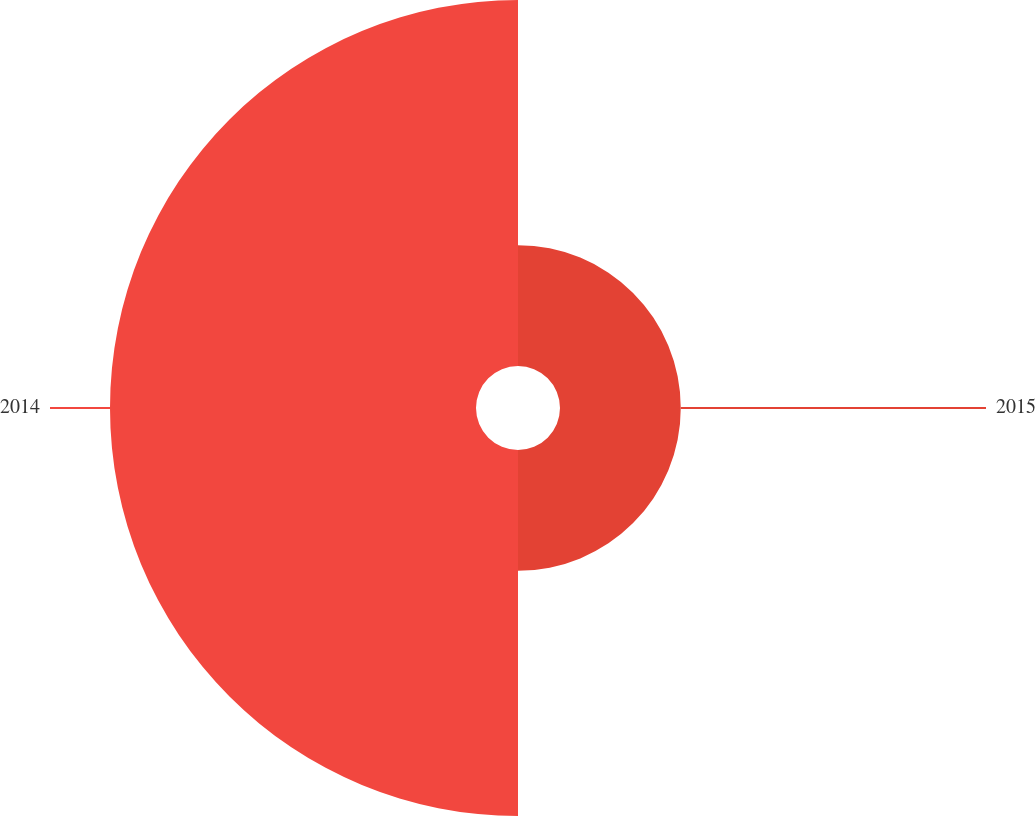Convert chart. <chart><loc_0><loc_0><loc_500><loc_500><pie_chart><fcel>2015<fcel>2014<nl><fcel>24.81%<fcel>75.19%<nl></chart> 